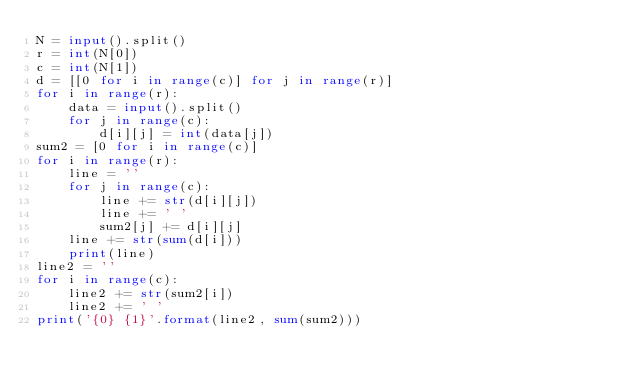<code> <loc_0><loc_0><loc_500><loc_500><_Python_>N = input().split()
r = int(N[0])
c = int(N[1])
d = [[0 for i in range(c)] for j in range(r)]
for i in range(r):
    data = input().split()
    for j in range(c):
        d[i][j] = int(data[j])
sum2 = [0 for i in range(c)]
for i in range(r):
    line = ''
    for j in range(c):
        line += str(d[i][j])
        line += ' '
        sum2[j] += d[i][j]
    line += str(sum(d[i]))
    print(line)
line2 = ''
for i in range(c):
    line2 += str(sum2[i])
    line2 += ' '
print('{0} {1}'.format(line2, sum(sum2)))</code> 